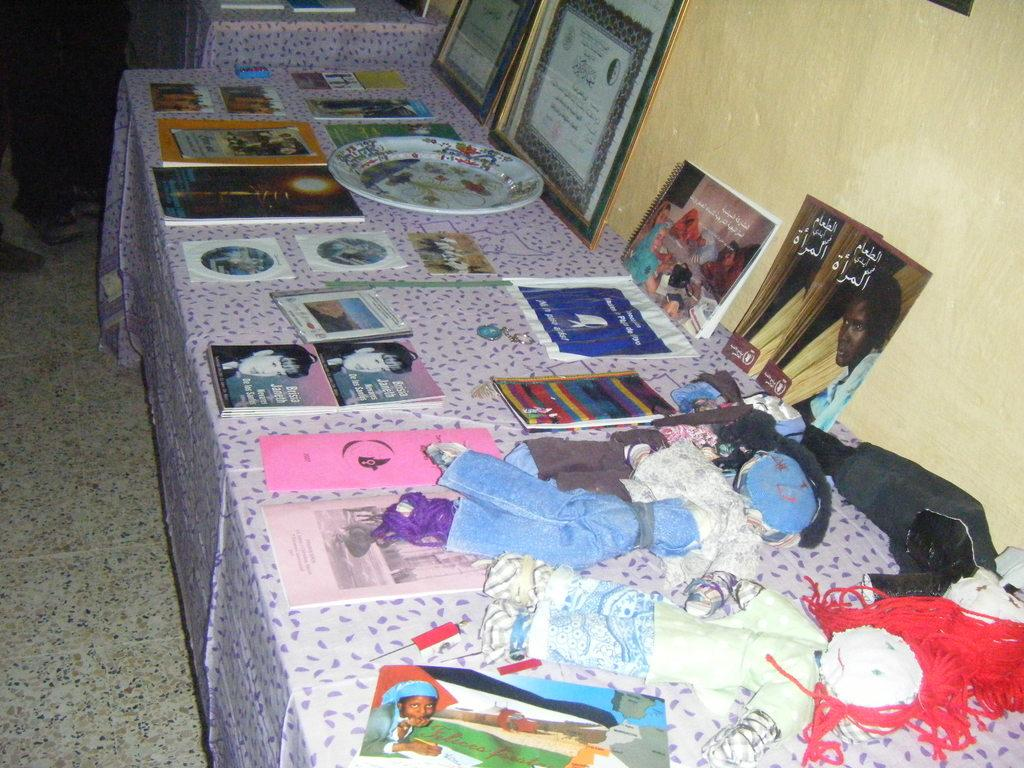What is the main object on the platform in the image? There is a platform with cloth in the image, and it contains toys, books, a plate, and photo frames. What type of items can be seen on the platform besides the mentioned ones? There are other unspecified items on the platform. What is visible on the right side of the image? There is a wall on the right side of the image. Can you see a horse or a scarecrow on the platform in the image? No, there is no horse or scarecrow present on the platform in the image. 